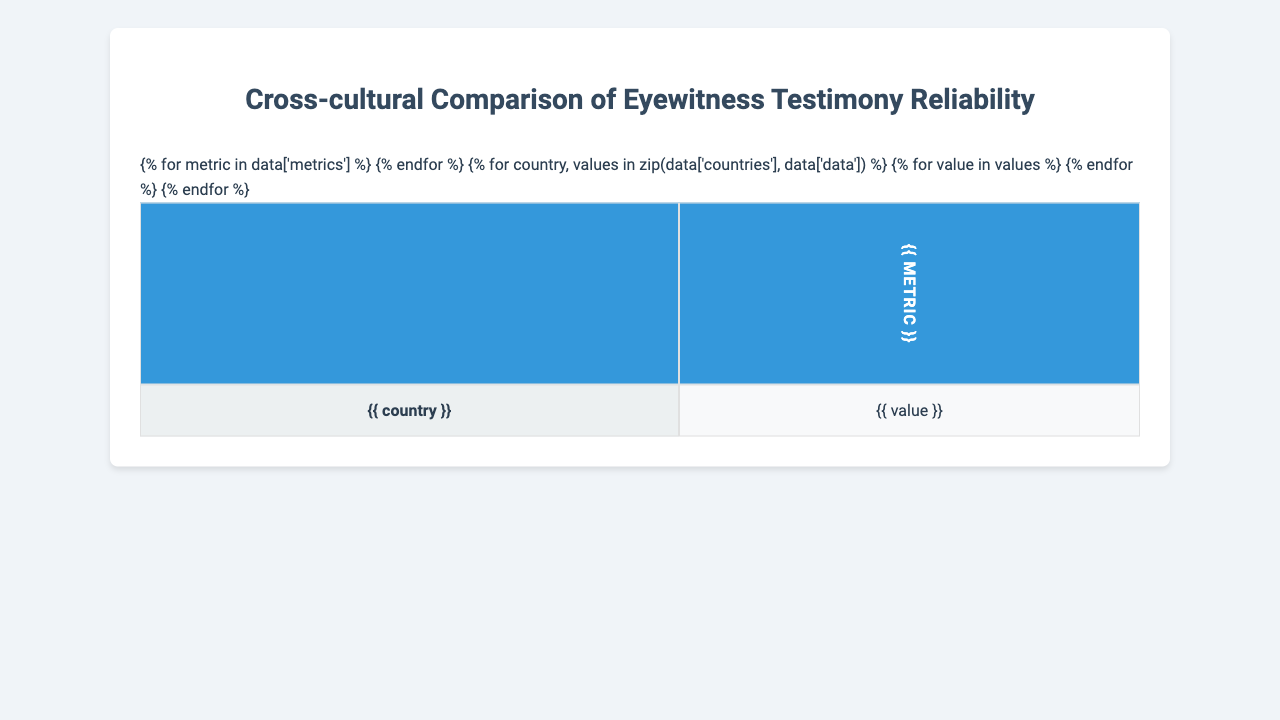What is the accuracy rate for eyewitness testimony in the United States? The table lists the accuracy rate for the United States as 78%.
Answer: 78% What country has the highest false identification rate? According to the table, Nigeria has the highest false identification rate at 19%.
Answer: Nigeria What is the memory decay rate for Germany? The memory decay rate for Germany is 3.0% per week as stated in the table.
Answer: 3.0% Which country shows the lowest confidence-accuracy correlation? The lowest confidence-accuracy correlation is found in Nigeria at 0.58.
Answer: Nigeria What is the cross-race effect for India? The table shows that the cross-race effect for India is 6%.
Answer: 6% What is the average accuracy rate across all countries? The accuracy rates for all countries are 78, 82, 73, 80, 75, and 76. Summing these gives 464, and dividing by 6 gives an average of 77.33.
Answer: 77.33 How much more percentage accuracy does Japan have over Nigeria? Japan's accuracy rate is 82%, and Nigeria's is 73%. The difference is 82 - 73 = 9%.
Answer: 9% If you combine the stress impact percentages of India and Brazil, what is the result? The stress impact percentages for India and Brazil are 20% and 19%, respectively. Adding them gives 20 + 19 = 39%.
Answer: 39% Is the confidence-accuracy correlation higher in Japan than in the United States? Japan's correlation is 0.71, while the United States' is 0.65, indicating that Japan does indeed have a higher correlation.
Answer: Yes Among the six countries, which one has the highest impact of stress on accuracy? The highest stress impact on accuracy is found in Nigeria at 22%.
Answer: Nigeria What is the difference in memory decay between the highest and lowest values recorded? The highest memory decay is in Nigeria at 3.7%, and the lowest is in Japan at 2.8%. The difference is 3.7 - 2.8 = 0.9%.
Answer: 0.9% 